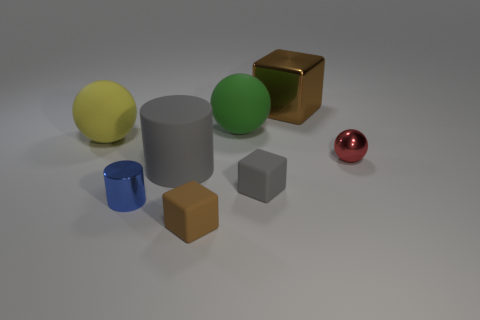Is the large yellow matte object the same shape as the big green object?
Offer a very short reply. Yes. Do the gray block and the green sphere have the same size?
Your answer should be compact. No. There is a gray cube; are there any tiny blue cylinders behind it?
Your answer should be very brief. No. What size is the ball that is to the right of the yellow ball and in front of the green sphere?
Your answer should be very brief. Small. How many things are green matte things or yellow spheres?
Your response must be concise. 2. Is the size of the matte cylinder the same as the block behind the large green matte thing?
Your answer should be very brief. Yes. What is the size of the brown block behind the tiny metallic thing that is left of the brown thing that is behind the big yellow ball?
Provide a succinct answer. Large. Are there any tiny rubber things?
Make the answer very short. Yes. There is a small thing that is the same color as the large block; what is it made of?
Make the answer very short. Rubber. What number of big metal objects are the same color as the metal cylinder?
Provide a short and direct response. 0. 